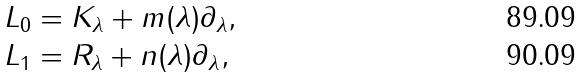<formula> <loc_0><loc_0><loc_500><loc_500>& L _ { 0 } = K _ { \lambda } + m ( \lambda ) \partial _ { \lambda } , \\ & L _ { 1 } = R _ { \lambda } + n ( \lambda ) \partial _ { \lambda } ,</formula> 